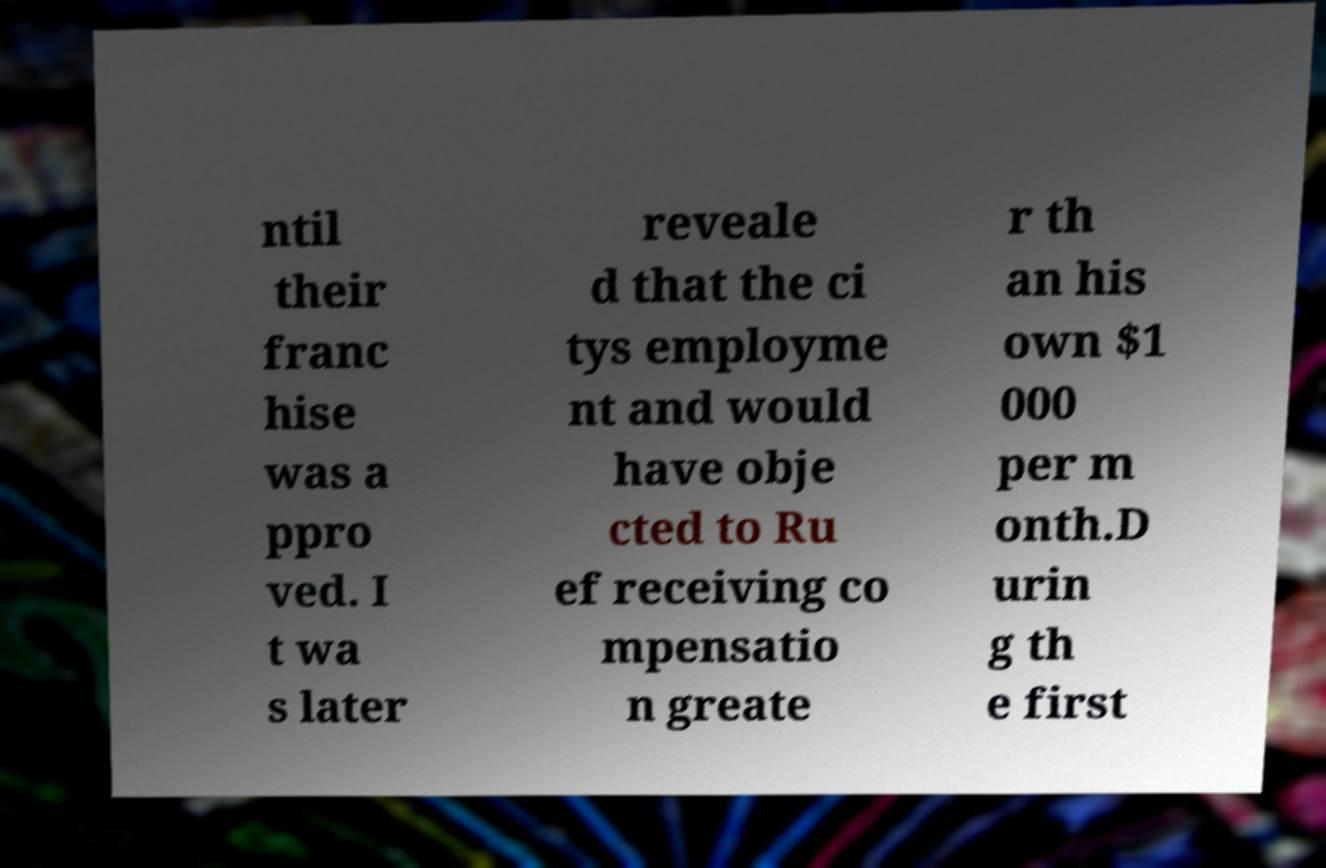There's text embedded in this image that I need extracted. Can you transcribe it verbatim? ntil their franc hise was a ppro ved. I t wa s later reveale d that the ci tys employme nt and would have obje cted to Ru ef receiving co mpensatio n greate r th an his own $1 000 per m onth.D urin g th e first 